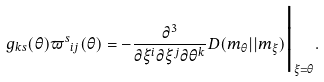Convert formula to latex. <formula><loc_0><loc_0><loc_500><loc_500>g _ { k s } ( \theta ) { \varpi ^ { s } } _ { i j } ( \theta ) = - \frac { \partial ^ { 3 } } { \partial \xi ^ { i } \partial \xi ^ { j } \partial \theta ^ { k } } D ( m _ { \theta } | | m _ { \xi } ) \Big | _ { \xi = \theta } .</formula> 